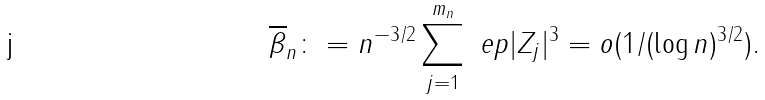<formula> <loc_0><loc_0><loc_500><loc_500>\overline { \beta } _ { n } \colon = n ^ { - 3 / 2 } \sum _ { j = 1 } ^ { m _ { n } } \ e p | Z _ { j } | ^ { 3 } = o ( 1 / ( \log n ) ^ { 3 / 2 } ) .</formula> 